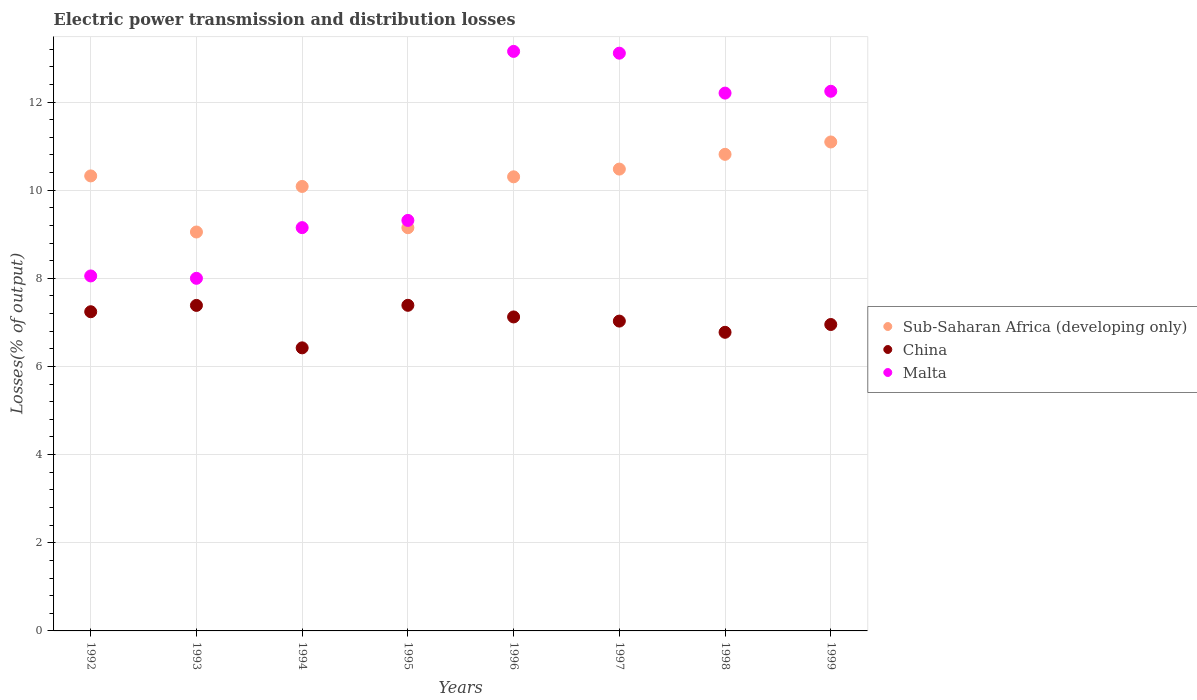How many different coloured dotlines are there?
Give a very brief answer. 3. What is the electric power transmission and distribution losses in China in 1994?
Provide a short and direct response. 6.42. Across all years, what is the maximum electric power transmission and distribution losses in Sub-Saharan Africa (developing only)?
Provide a short and direct response. 11.09. Across all years, what is the minimum electric power transmission and distribution losses in Sub-Saharan Africa (developing only)?
Provide a short and direct response. 9.05. In which year was the electric power transmission and distribution losses in Sub-Saharan Africa (developing only) maximum?
Your response must be concise. 1999. What is the total electric power transmission and distribution losses in Malta in the graph?
Provide a short and direct response. 85.22. What is the difference between the electric power transmission and distribution losses in Sub-Saharan Africa (developing only) in 1993 and that in 1995?
Ensure brevity in your answer.  -0.1. What is the difference between the electric power transmission and distribution losses in Sub-Saharan Africa (developing only) in 1993 and the electric power transmission and distribution losses in China in 1996?
Provide a short and direct response. 1.93. What is the average electric power transmission and distribution losses in Malta per year?
Provide a short and direct response. 10.65. In the year 1993, what is the difference between the electric power transmission and distribution losses in Sub-Saharan Africa (developing only) and electric power transmission and distribution losses in Malta?
Offer a very short reply. 1.05. In how many years, is the electric power transmission and distribution losses in Sub-Saharan Africa (developing only) greater than 1.6 %?
Your response must be concise. 8. What is the ratio of the electric power transmission and distribution losses in Malta in 1996 to that in 1999?
Provide a short and direct response. 1.07. Is the electric power transmission and distribution losses in Sub-Saharan Africa (developing only) in 1992 less than that in 1999?
Provide a short and direct response. Yes. Is the difference between the electric power transmission and distribution losses in Sub-Saharan Africa (developing only) in 1996 and 1998 greater than the difference between the electric power transmission and distribution losses in Malta in 1996 and 1998?
Offer a very short reply. No. What is the difference between the highest and the second highest electric power transmission and distribution losses in China?
Your answer should be very brief. 0. What is the difference between the highest and the lowest electric power transmission and distribution losses in Sub-Saharan Africa (developing only)?
Give a very brief answer. 2.04. In how many years, is the electric power transmission and distribution losses in Malta greater than the average electric power transmission and distribution losses in Malta taken over all years?
Your response must be concise. 4. Does the electric power transmission and distribution losses in China monotonically increase over the years?
Give a very brief answer. No. Is the electric power transmission and distribution losses in China strictly greater than the electric power transmission and distribution losses in Sub-Saharan Africa (developing only) over the years?
Offer a very short reply. No. Is the electric power transmission and distribution losses in Sub-Saharan Africa (developing only) strictly less than the electric power transmission and distribution losses in China over the years?
Keep it short and to the point. No. How many years are there in the graph?
Provide a short and direct response. 8. What is the difference between two consecutive major ticks on the Y-axis?
Ensure brevity in your answer.  2. How many legend labels are there?
Your response must be concise. 3. What is the title of the graph?
Keep it short and to the point. Electric power transmission and distribution losses. What is the label or title of the X-axis?
Your response must be concise. Years. What is the label or title of the Y-axis?
Ensure brevity in your answer.  Losses(% of output). What is the Losses(% of output) of Sub-Saharan Africa (developing only) in 1992?
Your answer should be very brief. 10.32. What is the Losses(% of output) in China in 1992?
Your answer should be compact. 7.24. What is the Losses(% of output) of Malta in 1992?
Your answer should be very brief. 8.05. What is the Losses(% of output) of Sub-Saharan Africa (developing only) in 1993?
Your answer should be compact. 9.05. What is the Losses(% of output) in China in 1993?
Offer a terse response. 7.39. What is the Losses(% of output) of Malta in 1993?
Provide a succinct answer. 8. What is the Losses(% of output) of Sub-Saharan Africa (developing only) in 1994?
Provide a short and direct response. 10.08. What is the Losses(% of output) in China in 1994?
Your answer should be very brief. 6.42. What is the Losses(% of output) in Malta in 1994?
Ensure brevity in your answer.  9.15. What is the Losses(% of output) of Sub-Saharan Africa (developing only) in 1995?
Your response must be concise. 9.15. What is the Losses(% of output) in China in 1995?
Offer a terse response. 7.39. What is the Losses(% of output) of Malta in 1995?
Provide a short and direct response. 9.31. What is the Losses(% of output) of Sub-Saharan Africa (developing only) in 1996?
Ensure brevity in your answer.  10.3. What is the Losses(% of output) in China in 1996?
Your answer should be very brief. 7.12. What is the Losses(% of output) in Malta in 1996?
Provide a short and direct response. 13.15. What is the Losses(% of output) in Sub-Saharan Africa (developing only) in 1997?
Make the answer very short. 10.48. What is the Losses(% of output) of China in 1997?
Provide a short and direct response. 7.03. What is the Losses(% of output) in Malta in 1997?
Keep it short and to the point. 13.11. What is the Losses(% of output) in Sub-Saharan Africa (developing only) in 1998?
Ensure brevity in your answer.  10.81. What is the Losses(% of output) in China in 1998?
Offer a terse response. 6.78. What is the Losses(% of output) in Malta in 1998?
Your answer should be compact. 12.2. What is the Losses(% of output) of Sub-Saharan Africa (developing only) in 1999?
Provide a succinct answer. 11.09. What is the Losses(% of output) of China in 1999?
Make the answer very short. 6.95. What is the Losses(% of output) of Malta in 1999?
Make the answer very short. 12.24. Across all years, what is the maximum Losses(% of output) in Sub-Saharan Africa (developing only)?
Offer a terse response. 11.09. Across all years, what is the maximum Losses(% of output) in China?
Give a very brief answer. 7.39. Across all years, what is the maximum Losses(% of output) in Malta?
Your answer should be compact. 13.15. Across all years, what is the minimum Losses(% of output) of Sub-Saharan Africa (developing only)?
Offer a very short reply. 9.05. Across all years, what is the minimum Losses(% of output) of China?
Keep it short and to the point. 6.42. What is the total Losses(% of output) of Sub-Saharan Africa (developing only) in the graph?
Make the answer very short. 81.29. What is the total Losses(% of output) of China in the graph?
Ensure brevity in your answer.  56.32. What is the total Losses(% of output) in Malta in the graph?
Your answer should be very brief. 85.22. What is the difference between the Losses(% of output) in Sub-Saharan Africa (developing only) in 1992 and that in 1993?
Your response must be concise. 1.27. What is the difference between the Losses(% of output) in China in 1992 and that in 1993?
Your answer should be compact. -0.14. What is the difference between the Losses(% of output) in Malta in 1992 and that in 1993?
Offer a very short reply. 0.05. What is the difference between the Losses(% of output) of Sub-Saharan Africa (developing only) in 1992 and that in 1994?
Make the answer very short. 0.24. What is the difference between the Losses(% of output) of China in 1992 and that in 1994?
Provide a short and direct response. 0.82. What is the difference between the Losses(% of output) in Malta in 1992 and that in 1994?
Make the answer very short. -1.1. What is the difference between the Losses(% of output) of Sub-Saharan Africa (developing only) in 1992 and that in 1995?
Your response must be concise. 1.18. What is the difference between the Losses(% of output) in China in 1992 and that in 1995?
Offer a very short reply. -0.15. What is the difference between the Losses(% of output) of Malta in 1992 and that in 1995?
Your answer should be compact. -1.26. What is the difference between the Losses(% of output) of Sub-Saharan Africa (developing only) in 1992 and that in 1996?
Ensure brevity in your answer.  0.02. What is the difference between the Losses(% of output) in China in 1992 and that in 1996?
Offer a very short reply. 0.12. What is the difference between the Losses(% of output) in Malta in 1992 and that in 1996?
Ensure brevity in your answer.  -5.09. What is the difference between the Losses(% of output) of Sub-Saharan Africa (developing only) in 1992 and that in 1997?
Ensure brevity in your answer.  -0.15. What is the difference between the Losses(% of output) of China in 1992 and that in 1997?
Your answer should be compact. 0.21. What is the difference between the Losses(% of output) of Malta in 1992 and that in 1997?
Your response must be concise. -5.05. What is the difference between the Losses(% of output) of Sub-Saharan Africa (developing only) in 1992 and that in 1998?
Keep it short and to the point. -0.49. What is the difference between the Losses(% of output) in China in 1992 and that in 1998?
Offer a terse response. 0.47. What is the difference between the Losses(% of output) of Malta in 1992 and that in 1998?
Offer a very short reply. -4.15. What is the difference between the Losses(% of output) of Sub-Saharan Africa (developing only) in 1992 and that in 1999?
Your response must be concise. -0.77. What is the difference between the Losses(% of output) in China in 1992 and that in 1999?
Provide a succinct answer. 0.29. What is the difference between the Losses(% of output) of Malta in 1992 and that in 1999?
Your answer should be compact. -4.19. What is the difference between the Losses(% of output) in Sub-Saharan Africa (developing only) in 1993 and that in 1994?
Offer a terse response. -1.03. What is the difference between the Losses(% of output) in China in 1993 and that in 1994?
Provide a succinct answer. 0.96. What is the difference between the Losses(% of output) in Malta in 1993 and that in 1994?
Your answer should be very brief. -1.15. What is the difference between the Losses(% of output) of Sub-Saharan Africa (developing only) in 1993 and that in 1995?
Ensure brevity in your answer.  -0.1. What is the difference between the Losses(% of output) of China in 1993 and that in 1995?
Your answer should be compact. -0. What is the difference between the Losses(% of output) of Malta in 1993 and that in 1995?
Make the answer very short. -1.31. What is the difference between the Losses(% of output) of Sub-Saharan Africa (developing only) in 1993 and that in 1996?
Offer a very short reply. -1.25. What is the difference between the Losses(% of output) of China in 1993 and that in 1996?
Your response must be concise. 0.26. What is the difference between the Losses(% of output) in Malta in 1993 and that in 1996?
Make the answer very short. -5.15. What is the difference between the Losses(% of output) in Sub-Saharan Africa (developing only) in 1993 and that in 1997?
Your answer should be compact. -1.43. What is the difference between the Losses(% of output) in China in 1993 and that in 1997?
Provide a succinct answer. 0.36. What is the difference between the Losses(% of output) of Malta in 1993 and that in 1997?
Provide a succinct answer. -5.11. What is the difference between the Losses(% of output) of Sub-Saharan Africa (developing only) in 1993 and that in 1998?
Offer a very short reply. -1.76. What is the difference between the Losses(% of output) in China in 1993 and that in 1998?
Keep it short and to the point. 0.61. What is the difference between the Losses(% of output) of Malta in 1993 and that in 1998?
Provide a short and direct response. -4.2. What is the difference between the Losses(% of output) in Sub-Saharan Africa (developing only) in 1993 and that in 1999?
Give a very brief answer. -2.04. What is the difference between the Losses(% of output) in China in 1993 and that in 1999?
Provide a short and direct response. 0.43. What is the difference between the Losses(% of output) in Malta in 1993 and that in 1999?
Your answer should be compact. -4.24. What is the difference between the Losses(% of output) in Sub-Saharan Africa (developing only) in 1994 and that in 1995?
Offer a terse response. 0.94. What is the difference between the Losses(% of output) in China in 1994 and that in 1995?
Ensure brevity in your answer.  -0.97. What is the difference between the Losses(% of output) in Malta in 1994 and that in 1995?
Ensure brevity in your answer.  -0.16. What is the difference between the Losses(% of output) of Sub-Saharan Africa (developing only) in 1994 and that in 1996?
Your answer should be compact. -0.22. What is the difference between the Losses(% of output) of China in 1994 and that in 1996?
Provide a short and direct response. -0.7. What is the difference between the Losses(% of output) of Malta in 1994 and that in 1996?
Provide a short and direct response. -4. What is the difference between the Losses(% of output) in Sub-Saharan Africa (developing only) in 1994 and that in 1997?
Ensure brevity in your answer.  -0.39. What is the difference between the Losses(% of output) in China in 1994 and that in 1997?
Your answer should be compact. -0.61. What is the difference between the Losses(% of output) in Malta in 1994 and that in 1997?
Offer a very short reply. -3.96. What is the difference between the Losses(% of output) in Sub-Saharan Africa (developing only) in 1994 and that in 1998?
Provide a succinct answer. -0.73. What is the difference between the Losses(% of output) in China in 1994 and that in 1998?
Give a very brief answer. -0.35. What is the difference between the Losses(% of output) of Malta in 1994 and that in 1998?
Give a very brief answer. -3.05. What is the difference between the Losses(% of output) in Sub-Saharan Africa (developing only) in 1994 and that in 1999?
Offer a terse response. -1.01. What is the difference between the Losses(% of output) in China in 1994 and that in 1999?
Your response must be concise. -0.53. What is the difference between the Losses(% of output) in Malta in 1994 and that in 1999?
Your answer should be very brief. -3.09. What is the difference between the Losses(% of output) in Sub-Saharan Africa (developing only) in 1995 and that in 1996?
Provide a short and direct response. -1.15. What is the difference between the Losses(% of output) in China in 1995 and that in 1996?
Your answer should be very brief. 0.26. What is the difference between the Losses(% of output) of Malta in 1995 and that in 1996?
Your answer should be compact. -3.83. What is the difference between the Losses(% of output) of Sub-Saharan Africa (developing only) in 1995 and that in 1997?
Your answer should be very brief. -1.33. What is the difference between the Losses(% of output) of China in 1995 and that in 1997?
Your response must be concise. 0.36. What is the difference between the Losses(% of output) of Malta in 1995 and that in 1997?
Offer a terse response. -3.79. What is the difference between the Losses(% of output) of Sub-Saharan Africa (developing only) in 1995 and that in 1998?
Your response must be concise. -1.66. What is the difference between the Losses(% of output) of China in 1995 and that in 1998?
Make the answer very short. 0.61. What is the difference between the Losses(% of output) of Malta in 1995 and that in 1998?
Your response must be concise. -2.89. What is the difference between the Losses(% of output) of Sub-Saharan Africa (developing only) in 1995 and that in 1999?
Provide a succinct answer. -1.95. What is the difference between the Losses(% of output) in China in 1995 and that in 1999?
Your response must be concise. 0.44. What is the difference between the Losses(% of output) in Malta in 1995 and that in 1999?
Your response must be concise. -2.93. What is the difference between the Losses(% of output) in Sub-Saharan Africa (developing only) in 1996 and that in 1997?
Your answer should be very brief. -0.18. What is the difference between the Losses(% of output) of China in 1996 and that in 1997?
Ensure brevity in your answer.  0.09. What is the difference between the Losses(% of output) in Malta in 1996 and that in 1997?
Offer a terse response. 0.04. What is the difference between the Losses(% of output) in Sub-Saharan Africa (developing only) in 1996 and that in 1998?
Make the answer very short. -0.51. What is the difference between the Losses(% of output) in China in 1996 and that in 1998?
Ensure brevity in your answer.  0.35. What is the difference between the Losses(% of output) of Malta in 1996 and that in 1998?
Your answer should be very brief. 0.95. What is the difference between the Losses(% of output) in Sub-Saharan Africa (developing only) in 1996 and that in 1999?
Make the answer very short. -0.79. What is the difference between the Losses(% of output) of China in 1996 and that in 1999?
Your answer should be very brief. 0.17. What is the difference between the Losses(% of output) of Malta in 1996 and that in 1999?
Your response must be concise. 0.9. What is the difference between the Losses(% of output) of Sub-Saharan Africa (developing only) in 1997 and that in 1998?
Your response must be concise. -0.33. What is the difference between the Losses(% of output) of China in 1997 and that in 1998?
Make the answer very short. 0.25. What is the difference between the Losses(% of output) of Malta in 1997 and that in 1998?
Your response must be concise. 0.91. What is the difference between the Losses(% of output) of Sub-Saharan Africa (developing only) in 1997 and that in 1999?
Give a very brief answer. -0.62. What is the difference between the Losses(% of output) in China in 1997 and that in 1999?
Give a very brief answer. 0.08. What is the difference between the Losses(% of output) in Malta in 1997 and that in 1999?
Provide a short and direct response. 0.86. What is the difference between the Losses(% of output) of Sub-Saharan Africa (developing only) in 1998 and that in 1999?
Keep it short and to the point. -0.28. What is the difference between the Losses(% of output) of China in 1998 and that in 1999?
Make the answer very short. -0.18. What is the difference between the Losses(% of output) of Malta in 1998 and that in 1999?
Your answer should be very brief. -0.04. What is the difference between the Losses(% of output) in Sub-Saharan Africa (developing only) in 1992 and the Losses(% of output) in China in 1993?
Your answer should be very brief. 2.94. What is the difference between the Losses(% of output) in Sub-Saharan Africa (developing only) in 1992 and the Losses(% of output) in Malta in 1993?
Provide a succinct answer. 2.32. What is the difference between the Losses(% of output) of China in 1992 and the Losses(% of output) of Malta in 1993?
Give a very brief answer. -0.76. What is the difference between the Losses(% of output) of Sub-Saharan Africa (developing only) in 1992 and the Losses(% of output) of China in 1994?
Your answer should be very brief. 3.9. What is the difference between the Losses(% of output) in Sub-Saharan Africa (developing only) in 1992 and the Losses(% of output) in Malta in 1994?
Give a very brief answer. 1.17. What is the difference between the Losses(% of output) of China in 1992 and the Losses(% of output) of Malta in 1994?
Make the answer very short. -1.91. What is the difference between the Losses(% of output) of Sub-Saharan Africa (developing only) in 1992 and the Losses(% of output) of China in 1995?
Ensure brevity in your answer.  2.94. What is the difference between the Losses(% of output) in Sub-Saharan Africa (developing only) in 1992 and the Losses(% of output) in Malta in 1995?
Offer a terse response. 1.01. What is the difference between the Losses(% of output) in China in 1992 and the Losses(% of output) in Malta in 1995?
Your answer should be very brief. -2.07. What is the difference between the Losses(% of output) in Sub-Saharan Africa (developing only) in 1992 and the Losses(% of output) in China in 1996?
Keep it short and to the point. 3.2. What is the difference between the Losses(% of output) in Sub-Saharan Africa (developing only) in 1992 and the Losses(% of output) in Malta in 1996?
Offer a terse response. -2.83. What is the difference between the Losses(% of output) in China in 1992 and the Losses(% of output) in Malta in 1996?
Make the answer very short. -5.91. What is the difference between the Losses(% of output) of Sub-Saharan Africa (developing only) in 1992 and the Losses(% of output) of China in 1997?
Give a very brief answer. 3.29. What is the difference between the Losses(% of output) in Sub-Saharan Africa (developing only) in 1992 and the Losses(% of output) in Malta in 1997?
Offer a terse response. -2.78. What is the difference between the Losses(% of output) in China in 1992 and the Losses(% of output) in Malta in 1997?
Your response must be concise. -5.87. What is the difference between the Losses(% of output) of Sub-Saharan Africa (developing only) in 1992 and the Losses(% of output) of China in 1998?
Ensure brevity in your answer.  3.55. What is the difference between the Losses(% of output) of Sub-Saharan Africa (developing only) in 1992 and the Losses(% of output) of Malta in 1998?
Keep it short and to the point. -1.88. What is the difference between the Losses(% of output) in China in 1992 and the Losses(% of output) in Malta in 1998?
Your response must be concise. -4.96. What is the difference between the Losses(% of output) of Sub-Saharan Africa (developing only) in 1992 and the Losses(% of output) of China in 1999?
Offer a very short reply. 3.37. What is the difference between the Losses(% of output) of Sub-Saharan Africa (developing only) in 1992 and the Losses(% of output) of Malta in 1999?
Your answer should be compact. -1.92. What is the difference between the Losses(% of output) of China in 1992 and the Losses(% of output) of Malta in 1999?
Provide a short and direct response. -5. What is the difference between the Losses(% of output) of Sub-Saharan Africa (developing only) in 1993 and the Losses(% of output) of China in 1994?
Give a very brief answer. 2.63. What is the difference between the Losses(% of output) in Sub-Saharan Africa (developing only) in 1993 and the Losses(% of output) in Malta in 1994?
Give a very brief answer. -0.1. What is the difference between the Losses(% of output) in China in 1993 and the Losses(% of output) in Malta in 1994?
Offer a terse response. -1.76. What is the difference between the Losses(% of output) in Sub-Saharan Africa (developing only) in 1993 and the Losses(% of output) in China in 1995?
Offer a terse response. 1.66. What is the difference between the Losses(% of output) in Sub-Saharan Africa (developing only) in 1993 and the Losses(% of output) in Malta in 1995?
Provide a short and direct response. -0.26. What is the difference between the Losses(% of output) of China in 1993 and the Losses(% of output) of Malta in 1995?
Ensure brevity in your answer.  -1.93. What is the difference between the Losses(% of output) of Sub-Saharan Africa (developing only) in 1993 and the Losses(% of output) of China in 1996?
Make the answer very short. 1.93. What is the difference between the Losses(% of output) of Sub-Saharan Africa (developing only) in 1993 and the Losses(% of output) of Malta in 1996?
Offer a very short reply. -4.1. What is the difference between the Losses(% of output) of China in 1993 and the Losses(% of output) of Malta in 1996?
Your answer should be compact. -5.76. What is the difference between the Losses(% of output) in Sub-Saharan Africa (developing only) in 1993 and the Losses(% of output) in China in 1997?
Keep it short and to the point. 2.02. What is the difference between the Losses(% of output) in Sub-Saharan Africa (developing only) in 1993 and the Losses(% of output) in Malta in 1997?
Ensure brevity in your answer.  -4.06. What is the difference between the Losses(% of output) in China in 1993 and the Losses(% of output) in Malta in 1997?
Offer a terse response. -5.72. What is the difference between the Losses(% of output) of Sub-Saharan Africa (developing only) in 1993 and the Losses(% of output) of China in 1998?
Provide a short and direct response. 2.28. What is the difference between the Losses(% of output) in Sub-Saharan Africa (developing only) in 1993 and the Losses(% of output) in Malta in 1998?
Give a very brief answer. -3.15. What is the difference between the Losses(% of output) in China in 1993 and the Losses(% of output) in Malta in 1998?
Provide a succinct answer. -4.82. What is the difference between the Losses(% of output) in Sub-Saharan Africa (developing only) in 1993 and the Losses(% of output) in China in 1999?
Your answer should be very brief. 2.1. What is the difference between the Losses(% of output) in Sub-Saharan Africa (developing only) in 1993 and the Losses(% of output) in Malta in 1999?
Keep it short and to the point. -3.19. What is the difference between the Losses(% of output) of China in 1993 and the Losses(% of output) of Malta in 1999?
Provide a short and direct response. -4.86. What is the difference between the Losses(% of output) in Sub-Saharan Africa (developing only) in 1994 and the Losses(% of output) in China in 1995?
Offer a very short reply. 2.7. What is the difference between the Losses(% of output) in Sub-Saharan Africa (developing only) in 1994 and the Losses(% of output) in Malta in 1995?
Make the answer very short. 0.77. What is the difference between the Losses(% of output) in China in 1994 and the Losses(% of output) in Malta in 1995?
Give a very brief answer. -2.89. What is the difference between the Losses(% of output) of Sub-Saharan Africa (developing only) in 1994 and the Losses(% of output) of China in 1996?
Offer a terse response. 2.96. What is the difference between the Losses(% of output) in Sub-Saharan Africa (developing only) in 1994 and the Losses(% of output) in Malta in 1996?
Offer a terse response. -3.06. What is the difference between the Losses(% of output) in China in 1994 and the Losses(% of output) in Malta in 1996?
Keep it short and to the point. -6.73. What is the difference between the Losses(% of output) of Sub-Saharan Africa (developing only) in 1994 and the Losses(% of output) of China in 1997?
Give a very brief answer. 3.06. What is the difference between the Losses(% of output) of Sub-Saharan Africa (developing only) in 1994 and the Losses(% of output) of Malta in 1997?
Your answer should be compact. -3.02. What is the difference between the Losses(% of output) in China in 1994 and the Losses(% of output) in Malta in 1997?
Your answer should be very brief. -6.69. What is the difference between the Losses(% of output) in Sub-Saharan Africa (developing only) in 1994 and the Losses(% of output) in China in 1998?
Your response must be concise. 3.31. What is the difference between the Losses(% of output) of Sub-Saharan Africa (developing only) in 1994 and the Losses(% of output) of Malta in 1998?
Your answer should be compact. -2.12. What is the difference between the Losses(% of output) in China in 1994 and the Losses(% of output) in Malta in 1998?
Provide a short and direct response. -5.78. What is the difference between the Losses(% of output) of Sub-Saharan Africa (developing only) in 1994 and the Losses(% of output) of China in 1999?
Your answer should be very brief. 3.13. What is the difference between the Losses(% of output) of Sub-Saharan Africa (developing only) in 1994 and the Losses(% of output) of Malta in 1999?
Provide a short and direct response. -2.16. What is the difference between the Losses(% of output) of China in 1994 and the Losses(% of output) of Malta in 1999?
Make the answer very short. -5.82. What is the difference between the Losses(% of output) of Sub-Saharan Africa (developing only) in 1995 and the Losses(% of output) of China in 1996?
Give a very brief answer. 2.02. What is the difference between the Losses(% of output) of Sub-Saharan Africa (developing only) in 1995 and the Losses(% of output) of Malta in 1996?
Keep it short and to the point. -4. What is the difference between the Losses(% of output) of China in 1995 and the Losses(% of output) of Malta in 1996?
Offer a very short reply. -5.76. What is the difference between the Losses(% of output) of Sub-Saharan Africa (developing only) in 1995 and the Losses(% of output) of China in 1997?
Provide a short and direct response. 2.12. What is the difference between the Losses(% of output) in Sub-Saharan Africa (developing only) in 1995 and the Losses(% of output) in Malta in 1997?
Provide a short and direct response. -3.96. What is the difference between the Losses(% of output) in China in 1995 and the Losses(% of output) in Malta in 1997?
Offer a terse response. -5.72. What is the difference between the Losses(% of output) in Sub-Saharan Africa (developing only) in 1995 and the Losses(% of output) in China in 1998?
Provide a short and direct response. 2.37. What is the difference between the Losses(% of output) of Sub-Saharan Africa (developing only) in 1995 and the Losses(% of output) of Malta in 1998?
Your response must be concise. -3.05. What is the difference between the Losses(% of output) of China in 1995 and the Losses(% of output) of Malta in 1998?
Keep it short and to the point. -4.81. What is the difference between the Losses(% of output) of Sub-Saharan Africa (developing only) in 1995 and the Losses(% of output) of China in 1999?
Make the answer very short. 2.2. What is the difference between the Losses(% of output) in Sub-Saharan Africa (developing only) in 1995 and the Losses(% of output) in Malta in 1999?
Your response must be concise. -3.1. What is the difference between the Losses(% of output) of China in 1995 and the Losses(% of output) of Malta in 1999?
Your answer should be compact. -4.86. What is the difference between the Losses(% of output) in Sub-Saharan Africa (developing only) in 1996 and the Losses(% of output) in China in 1997?
Offer a terse response. 3.27. What is the difference between the Losses(% of output) of Sub-Saharan Africa (developing only) in 1996 and the Losses(% of output) of Malta in 1997?
Make the answer very short. -2.81. What is the difference between the Losses(% of output) of China in 1996 and the Losses(% of output) of Malta in 1997?
Provide a short and direct response. -5.98. What is the difference between the Losses(% of output) in Sub-Saharan Africa (developing only) in 1996 and the Losses(% of output) in China in 1998?
Your answer should be very brief. 3.53. What is the difference between the Losses(% of output) in Sub-Saharan Africa (developing only) in 1996 and the Losses(% of output) in Malta in 1998?
Provide a succinct answer. -1.9. What is the difference between the Losses(% of output) in China in 1996 and the Losses(% of output) in Malta in 1998?
Keep it short and to the point. -5.08. What is the difference between the Losses(% of output) in Sub-Saharan Africa (developing only) in 1996 and the Losses(% of output) in China in 1999?
Provide a short and direct response. 3.35. What is the difference between the Losses(% of output) of Sub-Saharan Africa (developing only) in 1996 and the Losses(% of output) of Malta in 1999?
Offer a terse response. -1.94. What is the difference between the Losses(% of output) in China in 1996 and the Losses(% of output) in Malta in 1999?
Your answer should be very brief. -5.12. What is the difference between the Losses(% of output) of Sub-Saharan Africa (developing only) in 1997 and the Losses(% of output) of China in 1998?
Your response must be concise. 3.7. What is the difference between the Losses(% of output) of Sub-Saharan Africa (developing only) in 1997 and the Losses(% of output) of Malta in 1998?
Ensure brevity in your answer.  -1.72. What is the difference between the Losses(% of output) in China in 1997 and the Losses(% of output) in Malta in 1998?
Make the answer very short. -5.17. What is the difference between the Losses(% of output) in Sub-Saharan Africa (developing only) in 1997 and the Losses(% of output) in China in 1999?
Provide a short and direct response. 3.53. What is the difference between the Losses(% of output) of Sub-Saharan Africa (developing only) in 1997 and the Losses(% of output) of Malta in 1999?
Provide a succinct answer. -1.77. What is the difference between the Losses(% of output) of China in 1997 and the Losses(% of output) of Malta in 1999?
Offer a terse response. -5.21. What is the difference between the Losses(% of output) in Sub-Saharan Africa (developing only) in 1998 and the Losses(% of output) in China in 1999?
Make the answer very short. 3.86. What is the difference between the Losses(% of output) in Sub-Saharan Africa (developing only) in 1998 and the Losses(% of output) in Malta in 1999?
Your answer should be compact. -1.43. What is the difference between the Losses(% of output) of China in 1998 and the Losses(% of output) of Malta in 1999?
Provide a short and direct response. -5.47. What is the average Losses(% of output) of Sub-Saharan Africa (developing only) per year?
Give a very brief answer. 10.16. What is the average Losses(% of output) of China per year?
Your answer should be compact. 7.04. What is the average Losses(% of output) in Malta per year?
Your response must be concise. 10.65. In the year 1992, what is the difference between the Losses(% of output) of Sub-Saharan Africa (developing only) and Losses(% of output) of China?
Ensure brevity in your answer.  3.08. In the year 1992, what is the difference between the Losses(% of output) of Sub-Saharan Africa (developing only) and Losses(% of output) of Malta?
Ensure brevity in your answer.  2.27. In the year 1992, what is the difference between the Losses(% of output) of China and Losses(% of output) of Malta?
Offer a terse response. -0.81. In the year 1993, what is the difference between the Losses(% of output) of Sub-Saharan Africa (developing only) and Losses(% of output) of China?
Make the answer very short. 1.67. In the year 1993, what is the difference between the Losses(% of output) of Sub-Saharan Africa (developing only) and Losses(% of output) of Malta?
Give a very brief answer. 1.05. In the year 1993, what is the difference between the Losses(% of output) in China and Losses(% of output) in Malta?
Your answer should be compact. -0.61. In the year 1994, what is the difference between the Losses(% of output) of Sub-Saharan Africa (developing only) and Losses(% of output) of China?
Give a very brief answer. 3.66. In the year 1994, what is the difference between the Losses(% of output) of Sub-Saharan Africa (developing only) and Losses(% of output) of Malta?
Make the answer very short. 0.93. In the year 1994, what is the difference between the Losses(% of output) in China and Losses(% of output) in Malta?
Provide a succinct answer. -2.73. In the year 1995, what is the difference between the Losses(% of output) in Sub-Saharan Africa (developing only) and Losses(% of output) in China?
Make the answer very short. 1.76. In the year 1995, what is the difference between the Losses(% of output) in Sub-Saharan Africa (developing only) and Losses(% of output) in Malta?
Your response must be concise. -0.17. In the year 1995, what is the difference between the Losses(% of output) in China and Losses(% of output) in Malta?
Ensure brevity in your answer.  -1.93. In the year 1996, what is the difference between the Losses(% of output) in Sub-Saharan Africa (developing only) and Losses(% of output) in China?
Keep it short and to the point. 3.18. In the year 1996, what is the difference between the Losses(% of output) in Sub-Saharan Africa (developing only) and Losses(% of output) in Malta?
Your response must be concise. -2.85. In the year 1996, what is the difference between the Losses(% of output) in China and Losses(% of output) in Malta?
Keep it short and to the point. -6.02. In the year 1997, what is the difference between the Losses(% of output) of Sub-Saharan Africa (developing only) and Losses(% of output) of China?
Offer a very short reply. 3.45. In the year 1997, what is the difference between the Losses(% of output) of Sub-Saharan Africa (developing only) and Losses(% of output) of Malta?
Ensure brevity in your answer.  -2.63. In the year 1997, what is the difference between the Losses(% of output) of China and Losses(% of output) of Malta?
Ensure brevity in your answer.  -6.08. In the year 1998, what is the difference between the Losses(% of output) in Sub-Saharan Africa (developing only) and Losses(% of output) in China?
Your answer should be very brief. 4.04. In the year 1998, what is the difference between the Losses(% of output) of Sub-Saharan Africa (developing only) and Losses(% of output) of Malta?
Make the answer very short. -1.39. In the year 1998, what is the difference between the Losses(% of output) of China and Losses(% of output) of Malta?
Offer a very short reply. -5.43. In the year 1999, what is the difference between the Losses(% of output) of Sub-Saharan Africa (developing only) and Losses(% of output) of China?
Your answer should be very brief. 4.14. In the year 1999, what is the difference between the Losses(% of output) of Sub-Saharan Africa (developing only) and Losses(% of output) of Malta?
Offer a terse response. -1.15. In the year 1999, what is the difference between the Losses(% of output) in China and Losses(% of output) in Malta?
Your answer should be compact. -5.29. What is the ratio of the Losses(% of output) of Sub-Saharan Africa (developing only) in 1992 to that in 1993?
Your answer should be very brief. 1.14. What is the ratio of the Losses(% of output) of China in 1992 to that in 1993?
Give a very brief answer. 0.98. What is the ratio of the Losses(% of output) of Sub-Saharan Africa (developing only) in 1992 to that in 1994?
Offer a very short reply. 1.02. What is the ratio of the Losses(% of output) in China in 1992 to that in 1994?
Ensure brevity in your answer.  1.13. What is the ratio of the Losses(% of output) of Malta in 1992 to that in 1994?
Offer a very short reply. 0.88. What is the ratio of the Losses(% of output) of Sub-Saharan Africa (developing only) in 1992 to that in 1995?
Keep it short and to the point. 1.13. What is the ratio of the Losses(% of output) of China in 1992 to that in 1995?
Make the answer very short. 0.98. What is the ratio of the Losses(% of output) in Malta in 1992 to that in 1995?
Provide a succinct answer. 0.86. What is the ratio of the Losses(% of output) in China in 1992 to that in 1996?
Keep it short and to the point. 1.02. What is the ratio of the Losses(% of output) in Malta in 1992 to that in 1996?
Make the answer very short. 0.61. What is the ratio of the Losses(% of output) in Sub-Saharan Africa (developing only) in 1992 to that in 1997?
Offer a very short reply. 0.99. What is the ratio of the Losses(% of output) of China in 1992 to that in 1997?
Your answer should be compact. 1.03. What is the ratio of the Losses(% of output) in Malta in 1992 to that in 1997?
Your response must be concise. 0.61. What is the ratio of the Losses(% of output) in Sub-Saharan Africa (developing only) in 1992 to that in 1998?
Your answer should be very brief. 0.95. What is the ratio of the Losses(% of output) of China in 1992 to that in 1998?
Keep it short and to the point. 1.07. What is the ratio of the Losses(% of output) in Malta in 1992 to that in 1998?
Make the answer very short. 0.66. What is the ratio of the Losses(% of output) of Sub-Saharan Africa (developing only) in 1992 to that in 1999?
Your answer should be compact. 0.93. What is the ratio of the Losses(% of output) in China in 1992 to that in 1999?
Ensure brevity in your answer.  1.04. What is the ratio of the Losses(% of output) of Malta in 1992 to that in 1999?
Provide a succinct answer. 0.66. What is the ratio of the Losses(% of output) in Sub-Saharan Africa (developing only) in 1993 to that in 1994?
Your answer should be very brief. 0.9. What is the ratio of the Losses(% of output) of China in 1993 to that in 1994?
Your answer should be very brief. 1.15. What is the ratio of the Losses(% of output) in Malta in 1993 to that in 1994?
Make the answer very short. 0.87. What is the ratio of the Losses(% of output) in Sub-Saharan Africa (developing only) in 1993 to that in 1995?
Provide a succinct answer. 0.99. What is the ratio of the Losses(% of output) of China in 1993 to that in 1995?
Your answer should be compact. 1. What is the ratio of the Losses(% of output) of Malta in 1993 to that in 1995?
Offer a very short reply. 0.86. What is the ratio of the Losses(% of output) in Sub-Saharan Africa (developing only) in 1993 to that in 1996?
Keep it short and to the point. 0.88. What is the ratio of the Losses(% of output) in China in 1993 to that in 1996?
Provide a succinct answer. 1.04. What is the ratio of the Losses(% of output) in Malta in 1993 to that in 1996?
Your answer should be compact. 0.61. What is the ratio of the Losses(% of output) of Sub-Saharan Africa (developing only) in 1993 to that in 1997?
Your response must be concise. 0.86. What is the ratio of the Losses(% of output) in China in 1993 to that in 1997?
Your answer should be compact. 1.05. What is the ratio of the Losses(% of output) of Malta in 1993 to that in 1997?
Provide a succinct answer. 0.61. What is the ratio of the Losses(% of output) in Sub-Saharan Africa (developing only) in 1993 to that in 1998?
Make the answer very short. 0.84. What is the ratio of the Losses(% of output) in China in 1993 to that in 1998?
Your answer should be compact. 1.09. What is the ratio of the Losses(% of output) in Malta in 1993 to that in 1998?
Your response must be concise. 0.66. What is the ratio of the Losses(% of output) in Sub-Saharan Africa (developing only) in 1993 to that in 1999?
Offer a very short reply. 0.82. What is the ratio of the Losses(% of output) of China in 1993 to that in 1999?
Your answer should be very brief. 1.06. What is the ratio of the Losses(% of output) in Malta in 1993 to that in 1999?
Offer a very short reply. 0.65. What is the ratio of the Losses(% of output) of Sub-Saharan Africa (developing only) in 1994 to that in 1995?
Your answer should be compact. 1.1. What is the ratio of the Losses(% of output) of China in 1994 to that in 1995?
Your answer should be compact. 0.87. What is the ratio of the Losses(% of output) of Malta in 1994 to that in 1995?
Provide a short and direct response. 0.98. What is the ratio of the Losses(% of output) in Sub-Saharan Africa (developing only) in 1994 to that in 1996?
Provide a succinct answer. 0.98. What is the ratio of the Losses(% of output) of China in 1994 to that in 1996?
Keep it short and to the point. 0.9. What is the ratio of the Losses(% of output) of Malta in 1994 to that in 1996?
Your answer should be compact. 0.7. What is the ratio of the Losses(% of output) of Sub-Saharan Africa (developing only) in 1994 to that in 1997?
Offer a very short reply. 0.96. What is the ratio of the Losses(% of output) of China in 1994 to that in 1997?
Your answer should be compact. 0.91. What is the ratio of the Losses(% of output) of Malta in 1994 to that in 1997?
Your answer should be compact. 0.7. What is the ratio of the Losses(% of output) of Sub-Saharan Africa (developing only) in 1994 to that in 1998?
Your answer should be compact. 0.93. What is the ratio of the Losses(% of output) of China in 1994 to that in 1998?
Your answer should be very brief. 0.95. What is the ratio of the Losses(% of output) in Malta in 1994 to that in 1998?
Your response must be concise. 0.75. What is the ratio of the Losses(% of output) in Sub-Saharan Africa (developing only) in 1994 to that in 1999?
Your answer should be very brief. 0.91. What is the ratio of the Losses(% of output) in China in 1994 to that in 1999?
Offer a very short reply. 0.92. What is the ratio of the Losses(% of output) of Malta in 1994 to that in 1999?
Your response must be concise. 0.75. What is the ratio of the Losses(% of output) of Sub-Saharan Africa (developing only) in 1995 to that in 1996?
Ensure brevity in your answer.  0.89. What is the ratio of the Losses(% of output) of China in 1995 to that in 1996?
Your response must be concise. 1.04. What is the ratio of the Losses(% of output) in Malta in 1995 to that in 1996?
Your response must be concise. 0.71. What is the ratio of the Losses(% of output) in Sub-Saharan Africa (developing only) in 1995 to that in 1997?
Keep it short and to the point. 0.87. What is the ratio of the Losses(% of output) in China in 1995 to that in 1997?
Keep it short and to the point. 1.05. What is the ratio of the Losses(% of output) in Malta in 1995 to that in 1997?
Provide a short and direct response. 0.71. What is the ratio of the Losses(% of output) in Sub-Saharan Africa (developing only) in 1995 to that in 1998?
Keep it short and to the point. 0.85. What is the ratio of the Losses(% of output) in China in 1995 to that in 1998?
Your answer should be compact. 1.09. What is the ratio of the Losses(% of output) in Malta in 1995 to that in 1998?
Your answer should be very brief. 0.76. What is the ratio of the Losses(% of output) in Sub-Saharan Africa (developing only) in 1995 to that in 1999?
Give a very brief answer. 0.82. What is the ratio of the Losses(% of output) of China in 1995 to that in 1999?
Give a very brief answer. 1.06. What is the ratio of the Losses(% of output) in Malta in 1995 to that in 1999?
Make the answer very short. 0.76. What is the ratio of the Losses(% of output) in Sub-Saharan Africa (developing only) in 1996 to that in 1997?
Ensure brevity in your answer.  0.98. What is the ratio of the Losses(% of output) in China in 1996 to that in 1997?
Offer a terse response. 1.01. What is the ratio of the Losses(% of output) of Sub-Saharan Africa (developing only) in 1996 to that in 1998?
Provide a succinct answer. 0.95. What is the ratio of the Losses(% of output) in China in 1996 to that in 1998?
Keep it short and to the point. 1.05. What is the ratio of the Losses(% of output) in Malta in 1996 to that in 1998?
Provide a succinct answer. 1.08. What is the ratio of the Losses(% of output) of Sub-Saharan Africa (developing only) in 1996 to that in 1999?
Your answer should be very brief. 0.93. What is the ratio of the Losses(% of output) of China in 1996 to that in 1999?
Make the answer very short. 1.02. What is the ratio of the Losses(% of output) in Malta in 1996 to that in 1999?
Make the answer very short. 1.07. What is the ratio of the Losses(% of output) in Sub-Saharan Africa (developing only) in 1997 to that in 1998?
Your response must be concise. 0.97. What is the ratio of the Losses(% of output) of China in 1997 to that in 1998?
Give a very brief answer. 1.04. What is the ratio of the Losses(% of output) of Malta in 1997 to that in 1998?
Offer a very short reply. 1.07. What is the ratio of the Losses(% of output) in Sub-Saharan Africa (developing only) in 1997 to that in 1999?
Your answer should be very brief. 0.94. What is the ratio of the Losses(% of output) of China in 1997 to that in 1999?
Ensure brevity in your answer.  1.01. What is the ratio of the Losses(% of output) in Malta in 1997 to that in 1999?
Provide a succinct answer. 1.07. What is the ratio of the Losses(% of output) in Sub-Saharan Africa (developing only) in 1998 to that in 1999?
Your answer should be very brief. 0.97. What is the ratio of the Losses(% of output) of China in 1998 to that in 1999?
Give a very brief answer. 0.97. What is the ratio of the Losses(% of output) in Malta in 1998 to that in 1999?
Offer a terse response. 1. What is the difference between the highest and the second highest Losses(% of output) in Sub-Saharan Africa (developing only)?
Provide a succinct answer. 0.28. What is the difference between the highest and the second highest Losses(% of output) in China?
Provide a short and direct response. 0. What is the difference between the highest and the second highest Losses(% of output) in Malta?
Give a very brief answer. 0.04. What is the difference between the highest and the lowest Losses(% of output) in Sub-Saharan Africa (developing only)?
Offer a terse response. 2.04. What is the difference between the highest and the lowest Losses(% of output) in China?
Provide a succinct answer. 0.97. What is the difference between the highest and the lowest Losses(% of output) in Malta?
Your response must be concise. 5.15. 